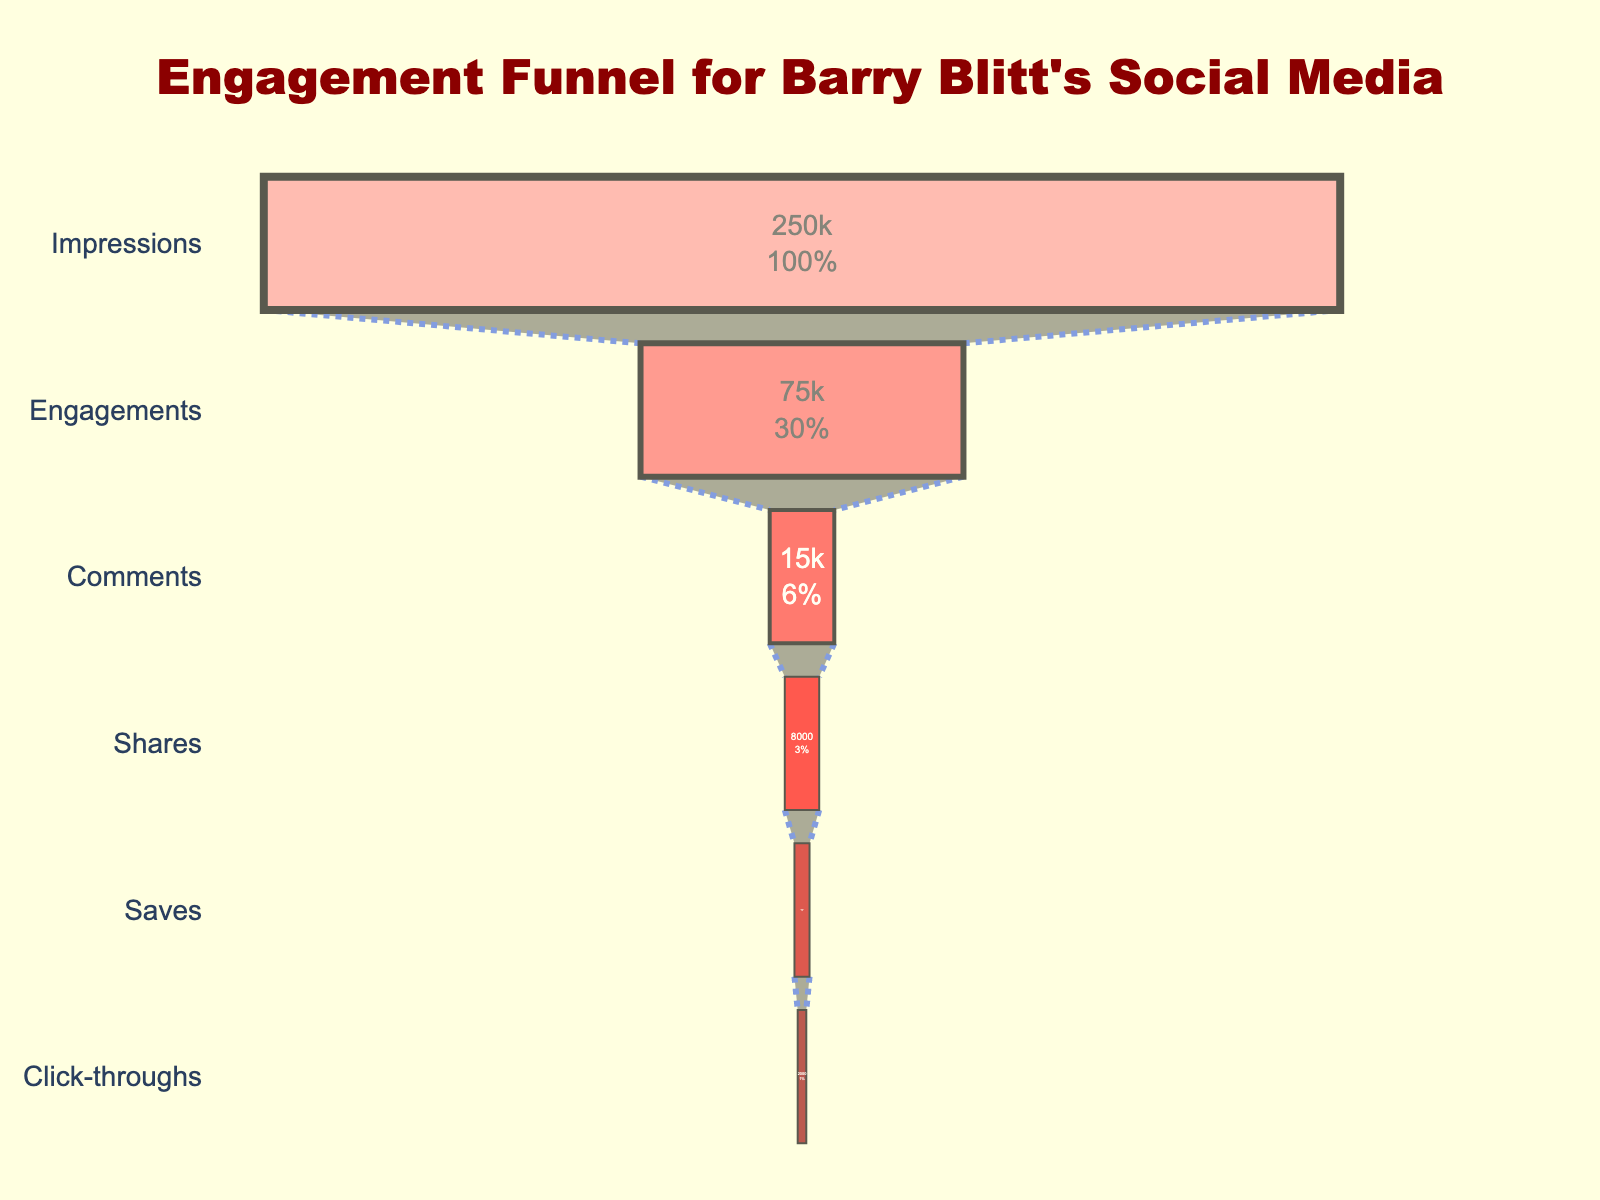What is the total number of impressions for Barry Blitt's social media posts? The total number of impressions can be found by looking at the "Impressions" stage in the funnel chart. The count associated with this stage is 250,000.
Answer: 250,000 How many likes and reactions are there? The number of likes and reactions is shown under the "Engagements" stage in the funnel chart. The count for this stage is 75,000.
Answer: 75,000 What percentage of total views converted into user comments? To find this, we need to divide the number of user comments by the total views and multiply by 100. According to the chart: (15,000 / 250,000) * 100 = 6%
Answer: 6% Which stage has the least engagement count, and what is that count? Observing the funnel chart, the "Click-throughs" stage has the least engagement count with a total of 2,000 visits to Blitt's website.
Answer: Click-throughs, 2,000 How many more likes and reactions are there compared to user comments? To find this, subtract the count of user comments from likes and reactions: 75,000 - 15,000 = 60,000.
Answer: 60,000 What is the percentage drop from impressions to engagements? The drop can be calculated by the formula ((Impressions - Engagements) / Impressions) * 100. Using the numbers: ((250,000 - 75,000) / 250,000) * 100 = 70%.
Answer: 70% Which stage comes between Engagements and Shares in the funnel chart? The funnel chart order shows "Comments" between "Engagements" and "Shares."
Answer: Comments How many stages are in the engagement funnel for Barry Blitt's social media posts? Counting the individual stages listed in the funnel chart, there are six stages: Impressions, Engagements, Comments, Shares, Saves, Click-throughs.
Answer: Six What stage has a count of 3,500, and what does it represent? The "Saves" stage has a count of 3,500, representing the number of saved illustrations.
Answer: Saves, Saved illustrations 